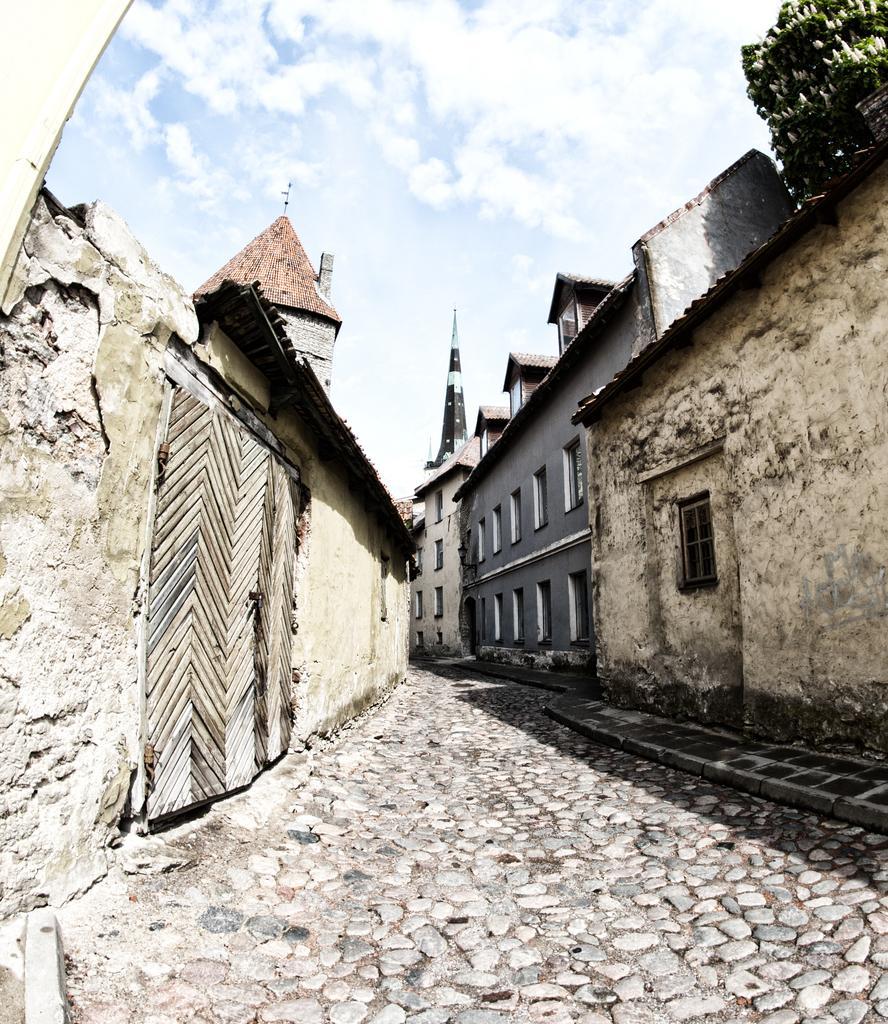Can you describe this image briefly? In this image, we can see a few buildings. We can see the ground. There are some plants with flowers on the top right. We can also see the sky with clouds. 